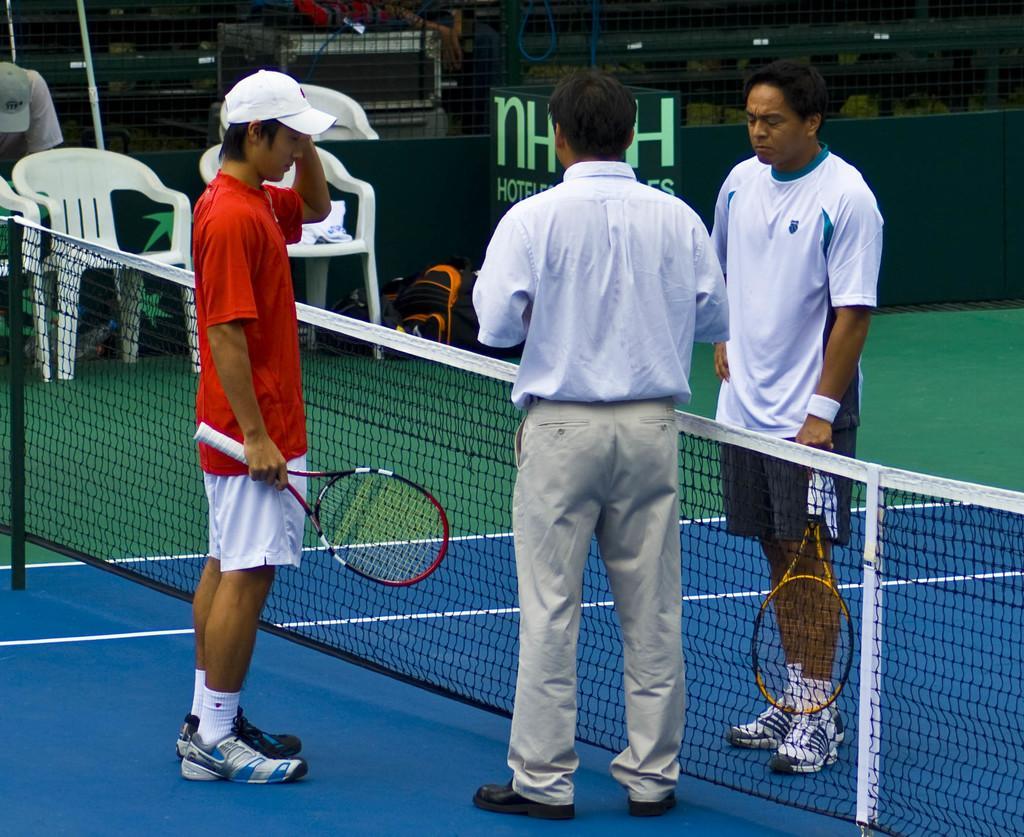Describe this image in one or two sentences. In this image I can see there are three persons standing in front of the fence and a person wearing a red color t-shirt and holding a bat and I can see two chairs kept on the ground in the middle and I can see a fence visible at the top., beside the chair I can see a backpacks kept on the ground. 